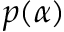<formula> <loc_0><loc_0><loc_500><loc_500>p ( \alpha )</formula> 